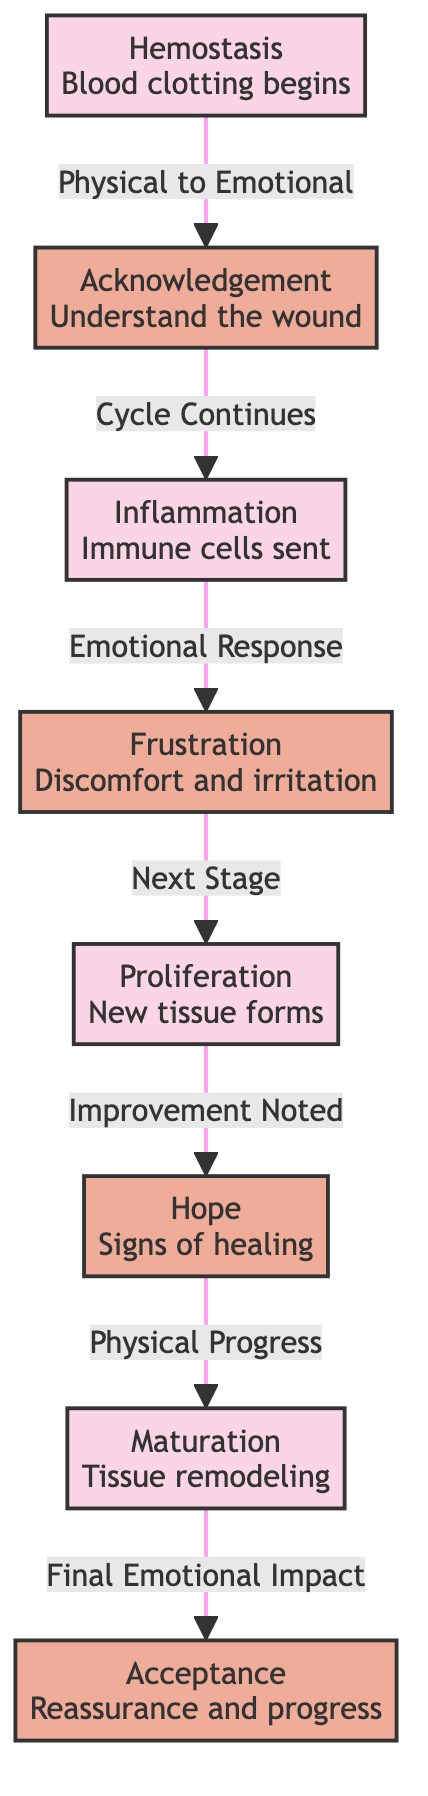What's the first stage of wound healing? The diagram shows the first stage labeled as "Hemostasis", which relates to the process of blood clotting.
Answer: Hemostasis How many emotional checkpoints are in the diagram? By examining the nodes specifically labeled as emotional checkpoints, there are four identified: Acknowledgement, Frustration, Hope, and Acceptance.
Answer: 4 What physical stage is followed by frustration? The diagram connects frustration (emotional) to the subsequent physical stage, which is Proliferation where new tissue forms.
Answer: Proliferation What is the emotional response after inflammation? Following the inflammation stage in the diagram, the emotional response labeled is Frustration.
Answer: Frustration What progression occurs after the hope stage? The hope stage, which indicates signs of healing, leads to the next physical stage identified as Maturation, where tissue remodeling occurs.
Answer: Maturation Does the emotional impact of healing become more positive or negative as shown? Analyzing the emotional impacts from the diagram, the progression moves from negative (Frustration) to positive (Acceptance), indicating an overall positive shift.
Answer: Positive Which two nodes are connected by the phrase "Cycle Continues"? The phrase "Cycle Continues" connects the emotional acknowledgment stage to the physical inflammation stage.
Answer: Acknowledgement and Inflammation In the maturation stage, what is the corresponding emotional checkpoint? The emotional checkpoint associated with the maturation physical stage is Acceptance, which represents reassurance and progress.
Answer: Acceptance 